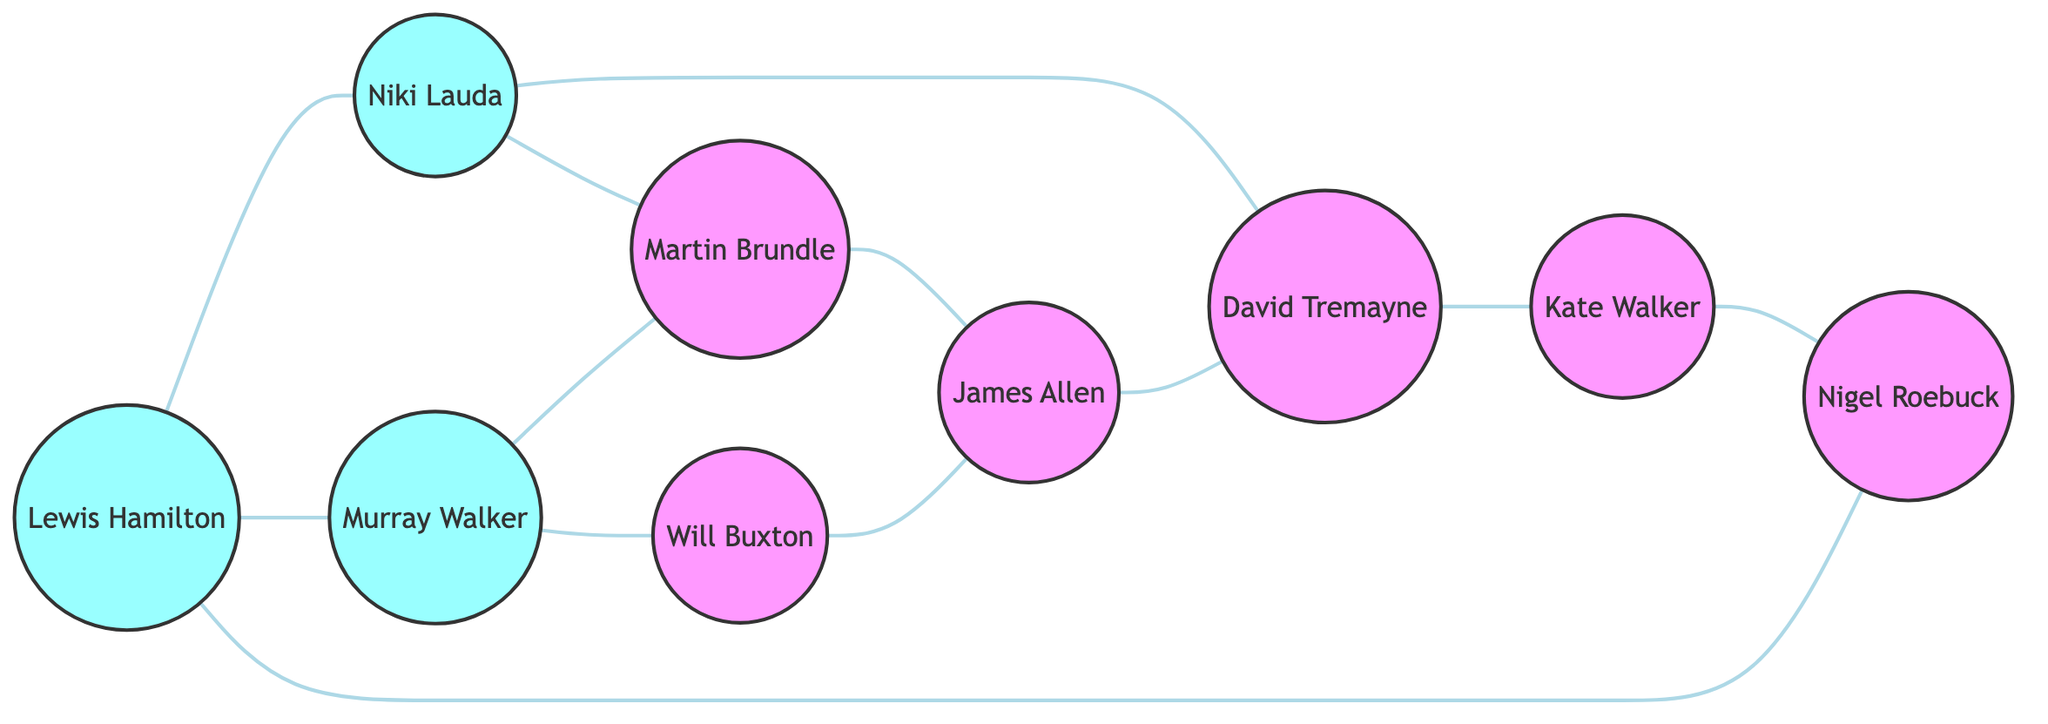What is the total number of nodes in the graph? The graph consists of a list of nodes which includes Lewis Hamilton, Niki Lauda, Murray Walker, Martin Brundle, Will Buxton, James Allen, David Tremayne, Kate Walker, and Nigel Roebuck. Counting these, we find that there are 9 nodes in total.
Answer: 9 Who has a direct connection with Niki Lauda? By examining the edges connected to Niki Lauda, we can see that he has direct connections with Lewis Hamilton, Martin Brundle, and David Tremayne. Therefore, the answer includes the names of these individuals to illustrate the direct connections.
Answer: Lewis Hamilton, Martin Brundle, David Tremayne How many edges are there in the graph? The graph contains various connections (edges) between the nodes. By enumerating the edges listed, we find that there are 12 edges in total.
Answer: 12 Which node is connected to both Martin Brundle and Will Buxton? Looking at the connections in the graph, we can find that both Martin Brundle and Will Buxton are connected through the node James Allen. This means James Allen is the node that acts as a bridge between Martin Brundle and Will Buxton.
Answer: James Allen Which node is the only one to connect back to Lewis Hamilton? Observing the edges, Nigel Roebuck has a direct connection to Lewis Hamilton, thus serving as the only node with this specific connection back to him. This allows us to identify Nigel Roebuck as the answer.
Answer: Nigel Roebuck How many mentors (highlighted in blue) are in the graph? The nodes that are labeled as mentors include Lewis Hamilton, Niki Lauda, and Murray Walker, all marked with a specific styling that indicates their status. Counting these highlighted nodes, we find there are 3 mentors in the graph.
Answer: 3 Which two nodes form a connection through James Allen? By examining the edges leading to and from James Allen, we can identify that Martin Brundle and Will Buxton are the nodes connected through James Allen in the graph. Thus, these two nodes directly link via James Allen.
Answer: Martin Brundle, Will Buxton What is the degree of the node representing Murray Walker? The degree of a node refers to the number of connections it has. For Murray Walker, looking at the edges, we find he connects to Niki Lauda, Martin Brundle, and Will Buxton. Thus, Murray Walker has a degree of 3, indicating the count of his direct connections.
Answer: 3 